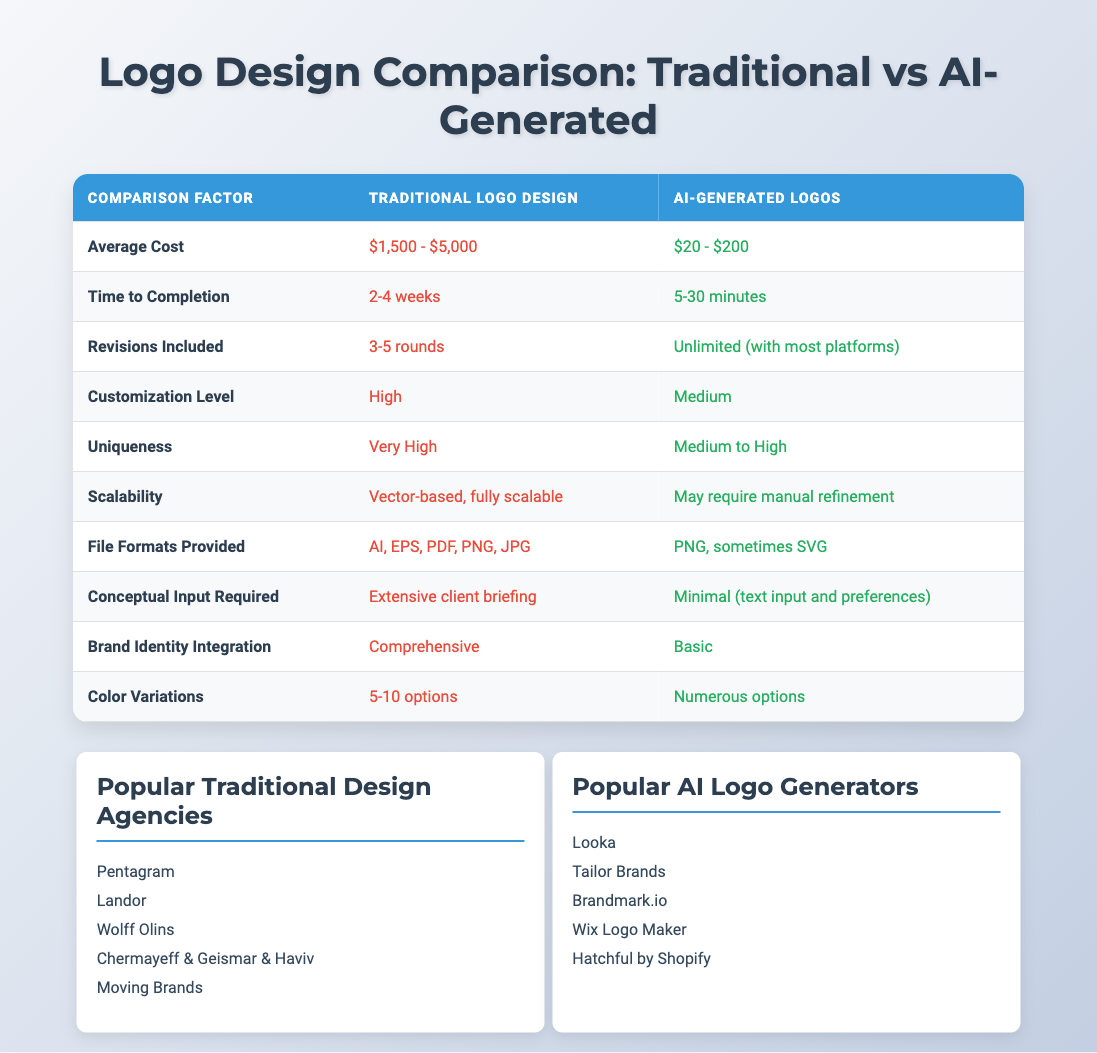What is the average cost range for traditional logo design? The table lists the average cost for traditional logo design as "$1,500 - $5,000". This is a direct retrieval from the table without any calculations needed.
Answer: $1,500 - $5,000 How long does it typically take to complete a traditional logo design? The table states that the time to completion for traditional logo design is "2-4 weeks". This is also a straightforward retrieval from the table.
Answer: 2-4 weeks Is there a difference in the number of revisions included between traditional and AI-generated logos? The traditional logo design allows "3-5 rounds" of revisions while AI-generated logos offer "Unlimited (with most platforms)". This indicates a clear difference, showing AI-generated logos provide more flexibility in revisions.
Answer: Yes What is the uniqueness level for AI-generated logos? According to the table, the uniqueness level for AI-generated logos is "Medium to High". This is straightforwardly derived from the data in the table.
Answer: Medium to High Which design option requires extensive conceptual input? The table mentions that traditional logo design requires "Extensive client briefing", while AI-generated logos require "Minimal (text input and preferences)". Thus, traditional logo design is the answer.
Answer: Traditional logo design How many file formats are provided for traditional logos compared to AI-generated logos? Traditional logos provide "AI, EPS, PDF, PNG, JPG", which is 5 different formats. AI-generated logos offer "PNG, sometimes SVG", totaling 2 formats. Therefore, traditional logos offer more formats.
Answer: Traditional logos provide more formats Given that color variations are numerous in AI-generated logos, can you summarize the options for traditional logos? The table specifies "5-10 options" for color variations in traditional logos, while AI-generated logos have "Numerous options". To summarize, traditional logos have a limited range of color options compared to AI-generated logos.
Answer: 5-10 options Compare the scalability of traditional logos to AI-generated logos Traditional logos are described as "Vector-based, fully scalable", whereas AI-generated logos "May require manual refinement". This indicates traditional logos have superior scalability compared to AI-generated logos.
Answer: Traditional logos are superior If you wanted a high level of customization, which option would be better? The table specifies "High" customization level for traditional logo design and "Medium" for AI-generated logos. Therefore, if high customization is a priority, traditional logo design is the better option.
Answer: Traditional logo design is better 